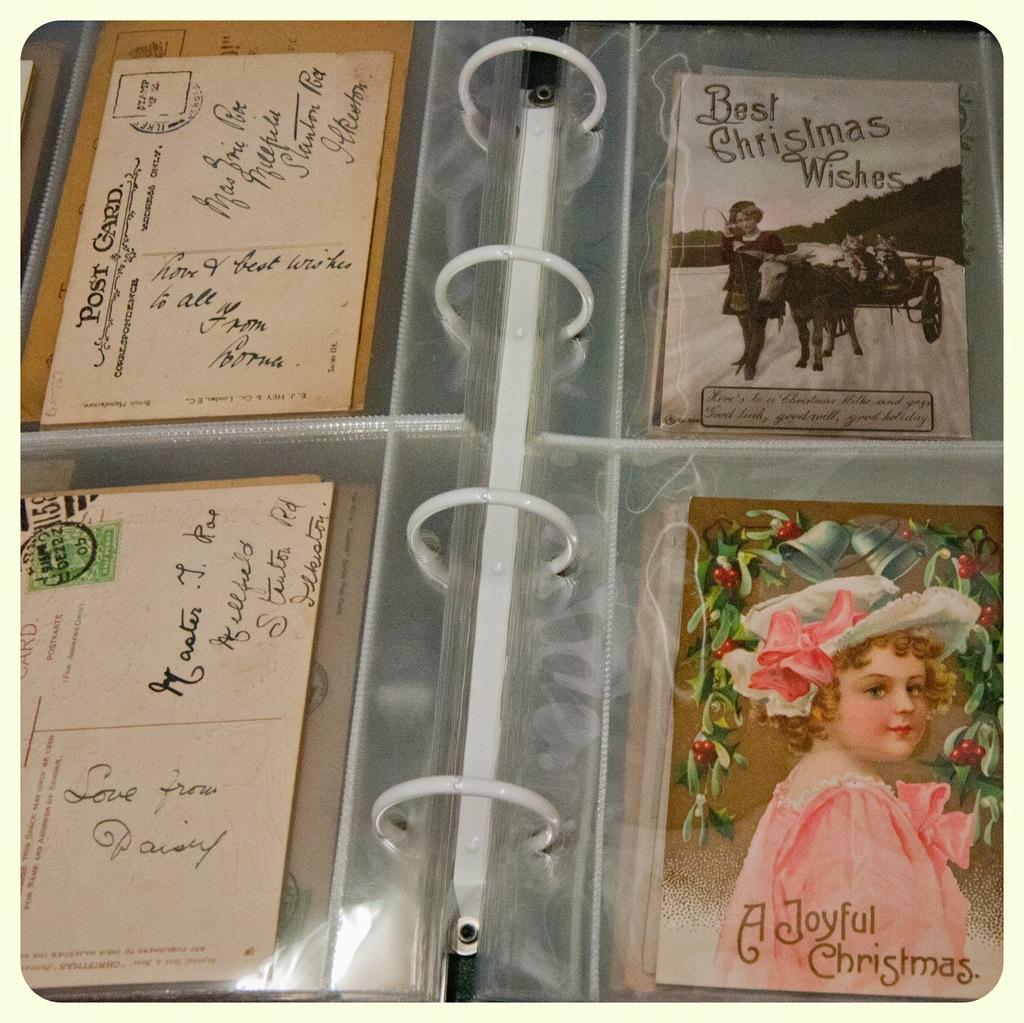How would you summarize this image in a sentence or two? In this picture I can see postcards and greeting cards in a photo album. 